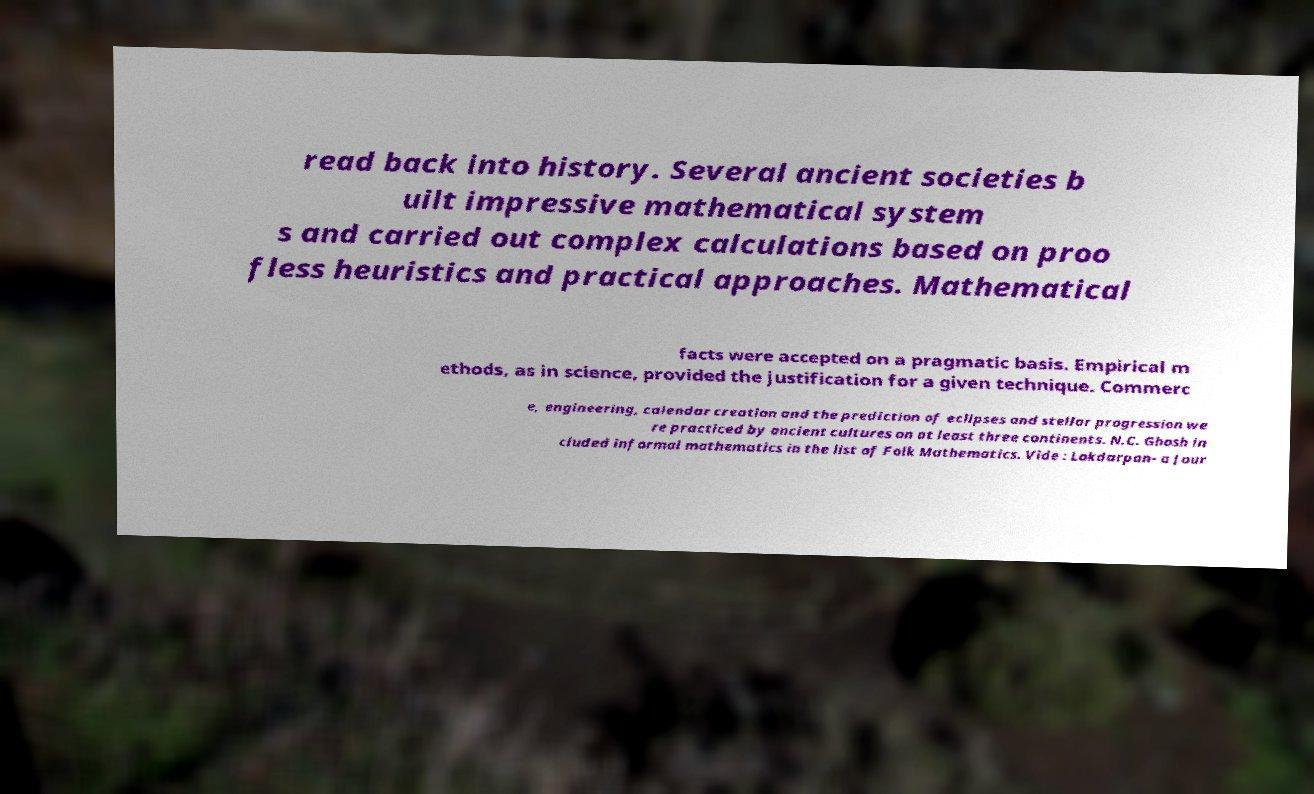I need the written content from this picture converted into text. Can you do that? read back into history. Several ancient societies b uilt impressive mathematical system s and carried out complex calculations based on proo fless heuristics and practical approaches. Mathematical facts were accepted on a pragmatic basis. Empirical m ethods, as in science, provided the justification for a given technique. Commerc e, engineering, calendar creation and the prediction of eclipses and stellar progression we re practiced by ancient cultures on at least three continents. N.C. Ghosh in cluded informal mathematics in the list of Folk Mathematics. Vide : Lokdarpan- a Jour 